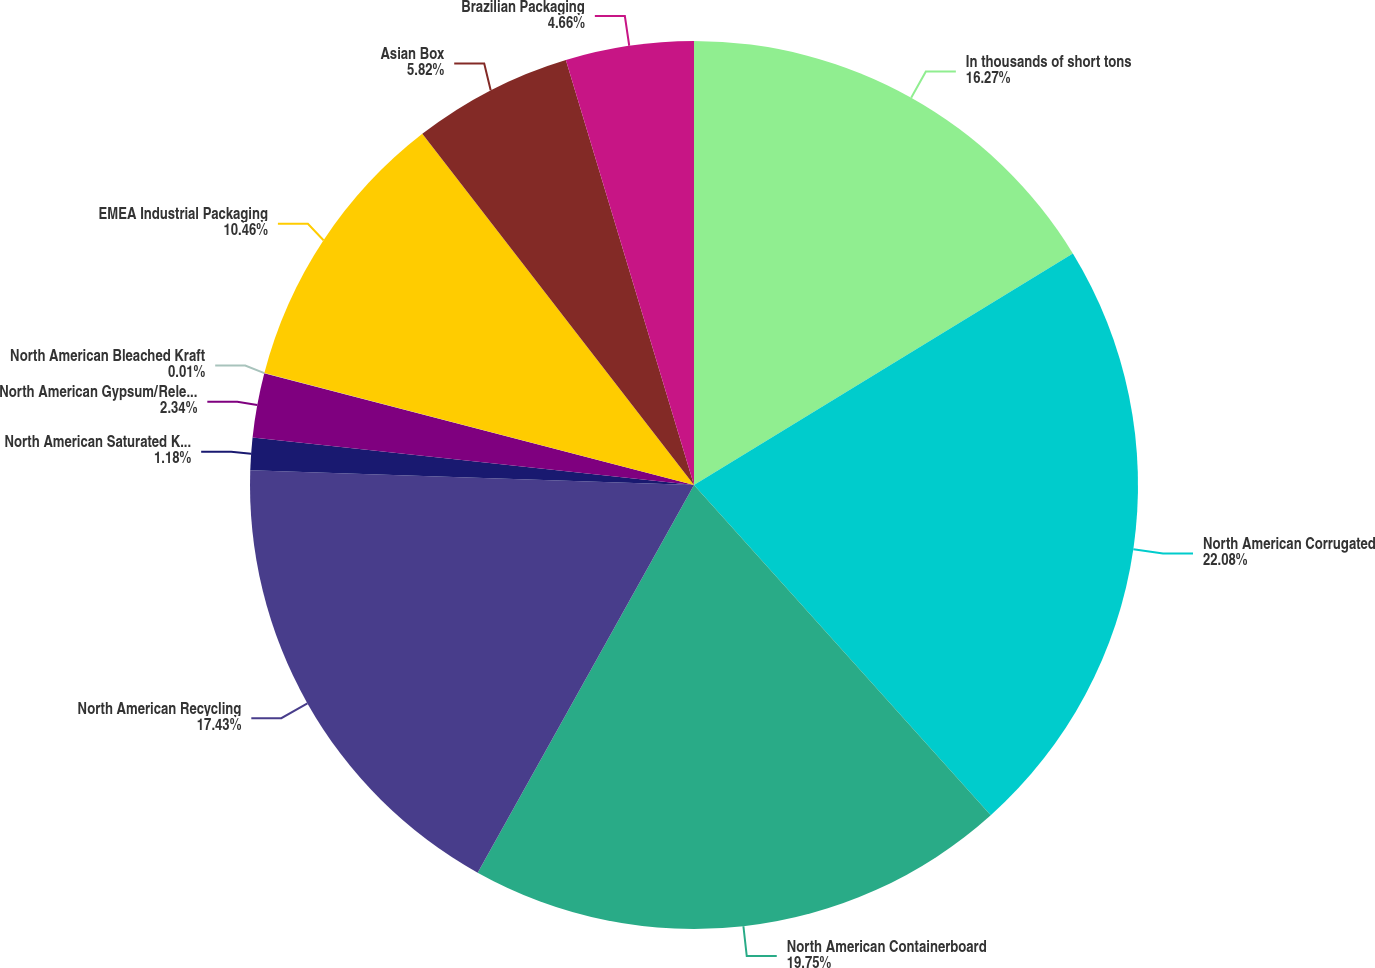Convert chart. <chart><loc_0><loc_0><loc_500><loc_500><pie_chart><fcel>In thousands of short tons<fcel>North American Corrugated<fcel>North American Containerboard<fcel>North American Recycling<fcel>North American Saturated Kraft<fcel>North American Gypsum/Release<fcel>North American Bleached Kraft<fcel>EMEA Industrial Packaging<fcel>Asian Box<fcel>Brazilian Packaging<nl><fcel>16.27%<fcel>22.08%<fcel>19.75%<fcel>17.43%<fcel>1.18%<fcel>2.34%<fcel>0.01%<fcel>10.46%<fcel>5.82%<fcel>4.66%<nl></chart> 